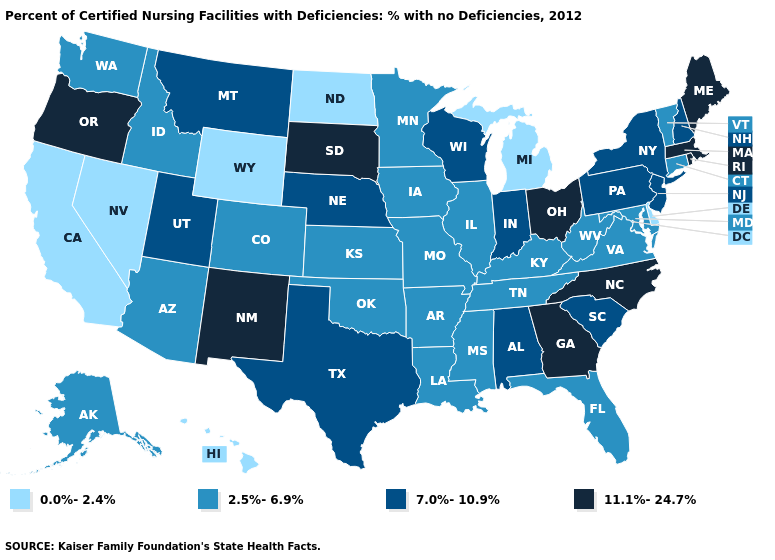What is the value of Montana?
Concise answer only. 7.0%-10.9%. What is the value of Washington?
Be succinct. 2.5%-6.9%. What is the value of Idaho?
Give a very brief answer. 2.5%-6.9%. How many symbols are there in the legend?
Short answer required. 4. Is the legend a continuous bar?
Give a very brief answer. No. What is the value of Wyoming?
Write a very short answer. 0.0%-2.4%. Name the states that have a value in the range 2.5%-6.9%?
Answer briefly. Alaska, Arizona, Arkansas, Colorado, Connecticut, Florida, Idaho, Illinois, Iowa, Kansas, Kentucky, Louisiana, Maryland, Minnesota, Mississippi, Missouri, Oklahoma, Tennessee, Vermont, Virginia, Washington, West Virginia. What is the highest value in the USA?
Write a very short answer. 11.1%-24.7%. Does New Mexico have a higher value than Alabama?
Be succinct. Yes. What is the value of Maryland?
Answer briefly. 2.5%-6.9%. Which states have the highest value in the USA?
Answer briefly. Georgia, Maine, Massachusetts, New Mexico, North Carolina, Ohio, Oregon, Rhode Island, South Dakota. How many symbols are there in the legend?
Give a very brief answer. 4. What is the value of Rhode Island?
Keep it brief. 11.1%-24.7%. Does Vermont have the lowest value in the Northeast?
Concise answer only. Yes. What is the value of Utah?
Concise answer only. 7.0%-10.9%. 